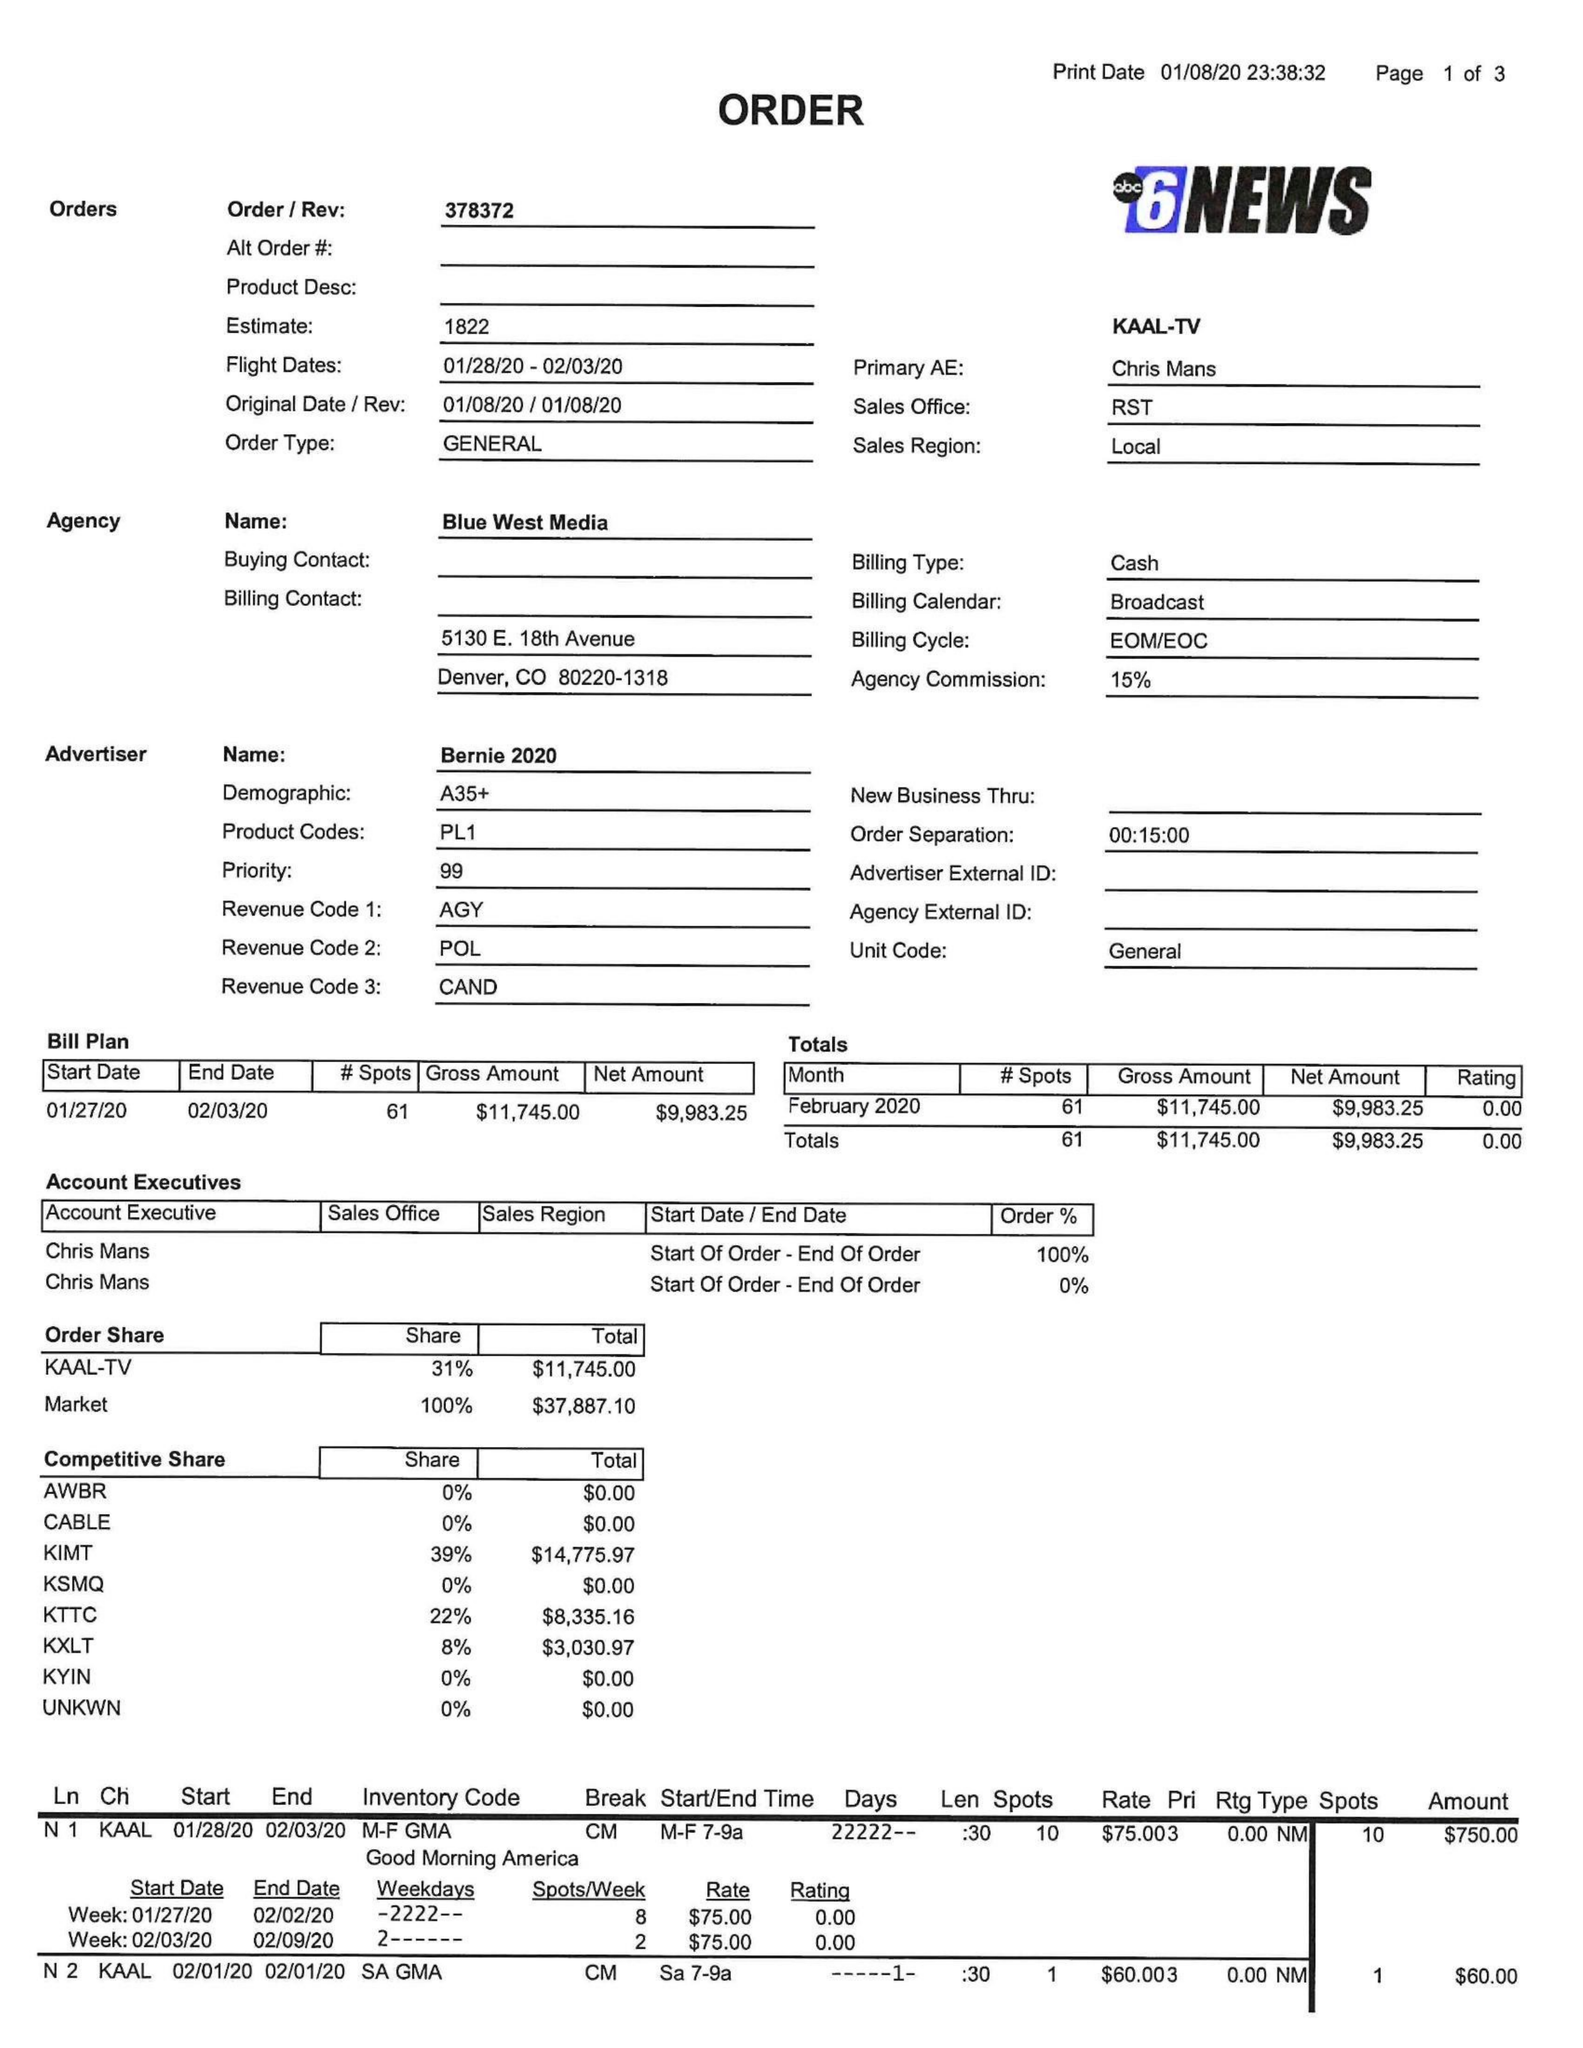What is the value for the contract_num?
Answer the question using a single word or phrase. 378372 